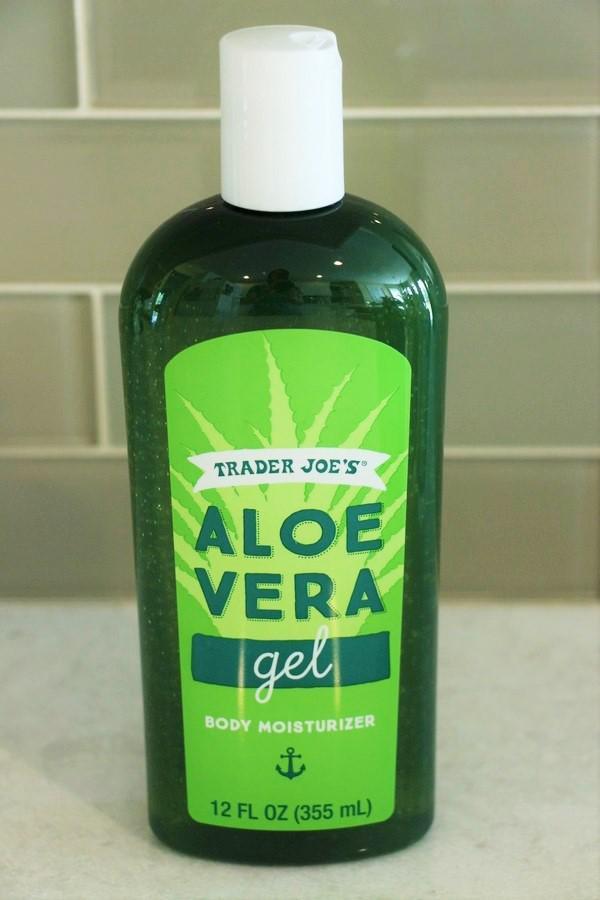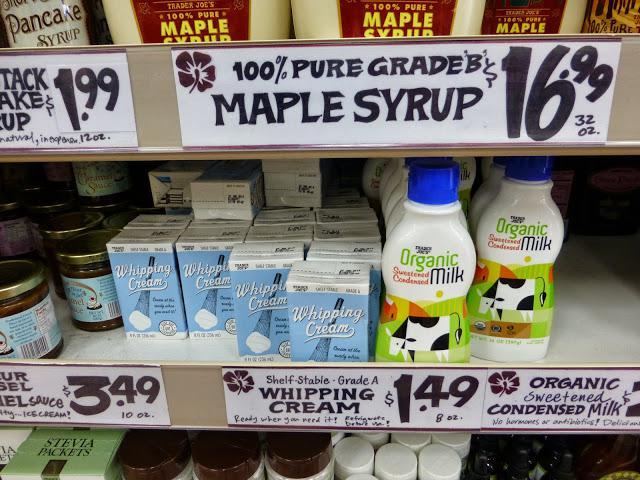The first image is the image on the left, the second image is the image on the right. For the images shown, is this caption "There is at least one spray bottle that contains multi purpose cleaner." true? Answer yes or no. No. The first image is the image on the left, the second image is the image on the right. Examine the images to the left and right. Is the description "There is a bottle with a squeeze trigger in the image on the right" accurate? Answer yes or no. No. 